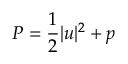<formula> <loc_0><loc_0><loc_500><loc_500>P = \frac { 1 } { 2 } | u | ^ { 2 } + p</formula> 